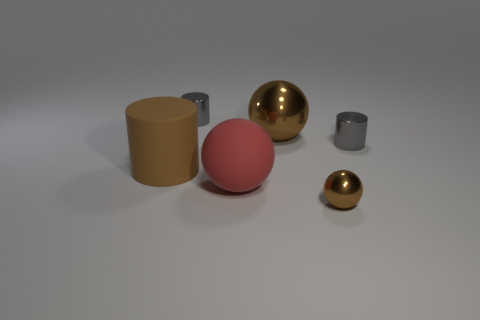There is a rubber thing to the right of the brown cylinder; does it have the same shape as the large thing that is behind the matte cylinder?
Offer a terse response. Yes. What number of other things are made of the same material as the large brown cylinder?
Make the answer very short. 1. Is the brown ball to the left of the tiny brown metallic thing made of the same material as the big brown cylinder that is on the left side of the big brown metal object?
Ensure brevity in your answer.  No. There is a big brown object that is made of the same material as the red thing; what is its shape?
Keep it short and to the point. Cylinder. Is there anything else that has the same color as the big matte cylinder?
Make the answer very short. Yes. What number of tiny spheres are there?
Give a very brief answer. 1. The brown thing that is on the right side of the brown cylinder and on the left side of the small brown metal object has what shape?
Make the answer very short. Sphere. The brown object on the left side of the small cylinder that is to the left of the small gray cylinder to the right of the red ball is what shape?
Make the answer very short. Cylinder. What material is the thing that is on the right side of the red object and in front of the large cylinder?
Keep it short and to the point. Metal. How many red things are the same size as the brown cylinder?
Make the answer very short. 1. 